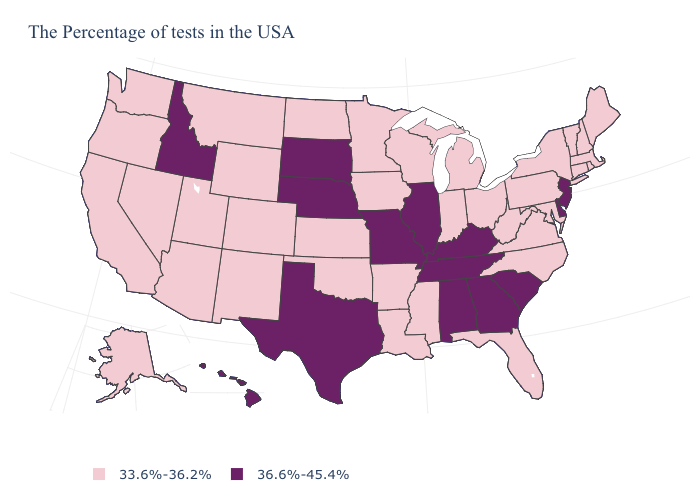Which states have the lowest value in the USA?
Quick response, please. Maine, Massachusetts, Rhode Island, New Hampshire, Vermont, Connecticut, New York, Maryland, Pennsylvania, Virginia, North Carolina, West Virginia, Ohio, Florida, Michigan, Indiana, Wisconsin, Mississippi, Louisiana, Arkansas, Minnesota, Iowa, Kansas, Oklahoma, North Dakota, Wyoming, Colorado, New Mexico, Utah, Montana, Arizona, Nevada, California, Washington, Oregon, Alaska. What is the value of Nebraska?
Quick response, please. 36.6%-45.4%. Among the states that border North Dakota , which have the highest value?
Be succinct. South Dakota. Which states hav the highest value in the Northeast?
Concise answer only. New Jersey. Does the first symbol in the legend represent the smallest category?
Give a very brief answer. Yes. What is the value of South Carolina?
Keep it brief. 36.6%-45.4%. Name the states that have a value in the range 36.6%-45.4%?
Concise answer only. New Jersey, Delaware, South Carolina, Georgia, Kentucky, Alabama, Tennessee, Illinois, Missouri, Nebraska, Texas, South Dakota, Idaho, Hawaii. What is the value of Louisiana?
Give a very brief answer. 33.6%-36.2%. What is the lowest value in the USA?
Concise answer only. 33.6%-36.2%. Which states have the highest value in the USA?
Answer briefly. New Jersey, Delaware, South Carolina, Georgia, Kentucky, Alabama, Tennessee, Illinois, Missouri, Nebraska, Texas, South Dakota, Idaho, Hawaii. Name the states that have a value in the range 33.6%-36.2%?
Give a very brief answer. Maine, Massachusetts, Rhode Island, New Hampshire, Vermont, Connecticut, New York, Maryland, Pennsylvania, Virginia, North Carolina, West Virginia, Ohio, Florida, Michigan, Indiana, Wisconsin, Mississippi, Louisiana, Arkansas, Minnesota, Iowa, Kansas, Oklahoma, North Dakota, Wyoming, Colorado, New Mexico, Utah, Montana, Arizona, Nevada, California, Washington, Oregon, Alaska. Among the states that border North Carolina , which have the lowest value?
Short answer required. Virginia. How many symbols are there in the legend?
Answer briefly. 2. What is the value of Kentucky?
Be succinct. 36.6%-45.4%. Name the states that have a value in the range 36.6%-45.4%?
Be succinct. New Jersey, Delaware, South Carolina, Georgia, Kentucky, Alabama, Tennessee, Illinois, Missouri, Nebraska, Texas, South Dakota, Idaho, Hawaii. 